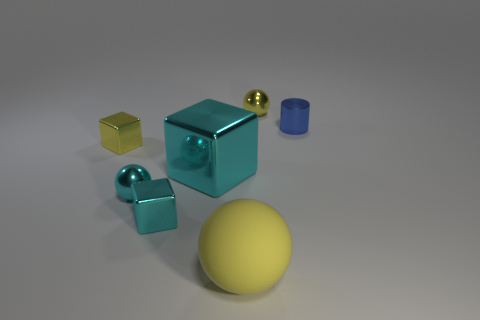Add 6 yellow blocks. How many yellow blocks are left? 7 Add 3 blue things. How many blue things exist? 4 Add 3 large cyan things. How many objects exist? 10 Subtract all yellow balls. How many balls are left? 1 Subtract all cyan metallic balls. How many balls are left? 2 Subtract 0 red spheres. How many objects are left? 7 Subtract all balls. How many objects are left? 4 Subtract 1 balls. How many balls are left? 2 Subtract all red spheres. Subtract all purple cubes. How many spheres are left? 3 Subtract all green cylinders. How many green blocks are left? 0 